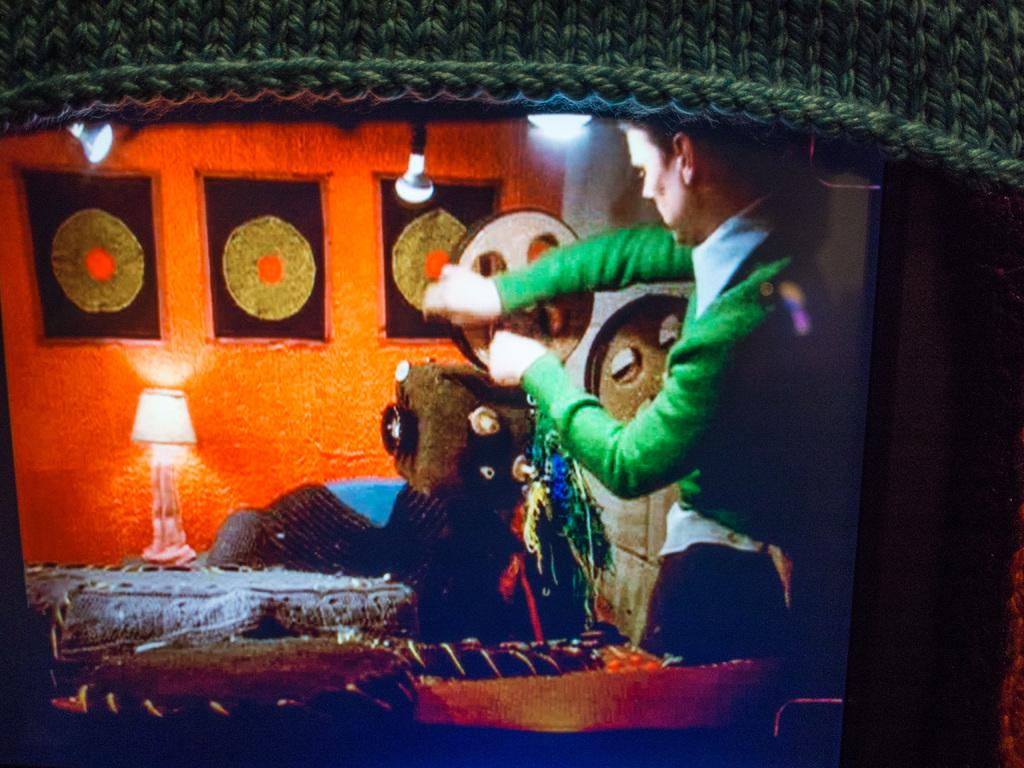What object is the person holding in the image? The person is holding a camera in the image. What can be seen in the background of the image? There is a building in the background of the image. How many geese are visible on the basketball court in the image? There are no geese visible on the basketball court in the image. 